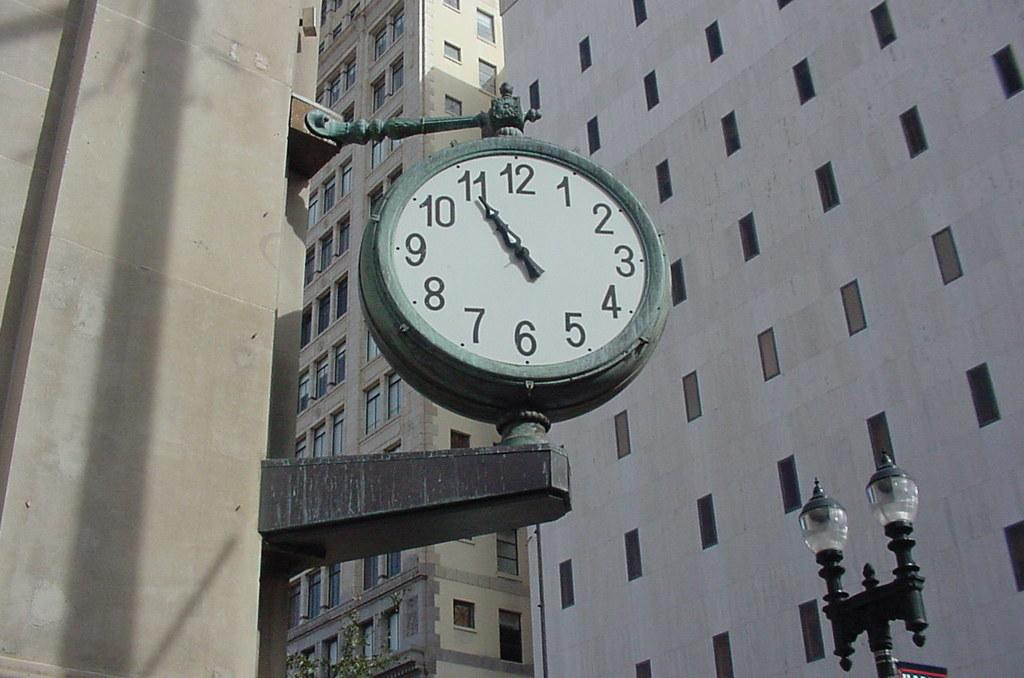What object is featured in the image that displays time? There is a clock in the image. Where is the clock located? The clock is attached to a building. What can be seen behind the clock in the image? There are two tall buildings behind the clock. What type of lighting fixture is visible on the right side of the image? There is a street light on the right side of the image. What type of haircut does the clock have in the image? The clock does not have a haircut, as it is an inanimate object. How many cherries are hanging from the street light in the image? There are no cherries present in the image; it features a clock, buildings, and a street light. 